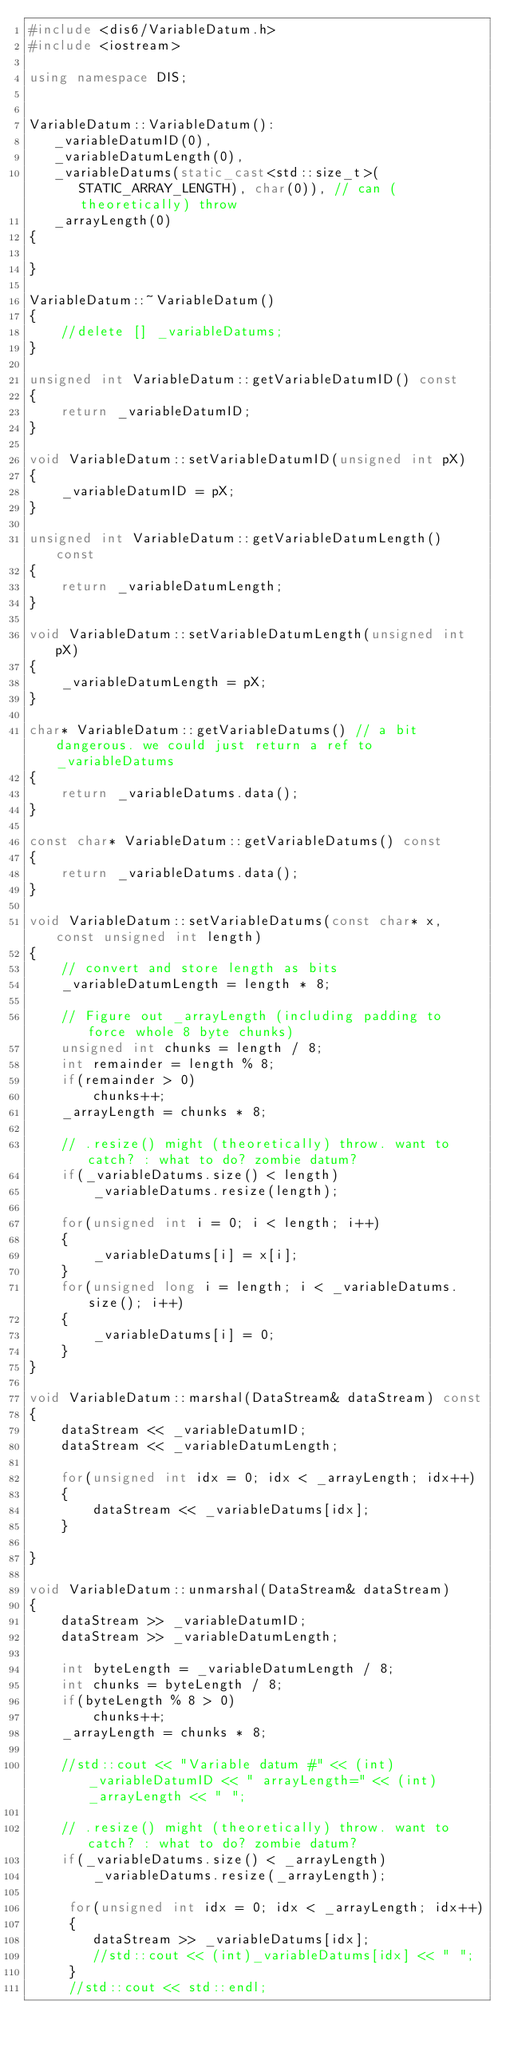Convert code to text. <code><loc_0><loc_0><loc_500><loc_500><_C++_>#include <dis6/VariableDatum.h>
#include <iostream>

using namespace DIS;


VariableDatum::VariableDatum():
   _variableDatumID(0), 
   _variableDatumLength(0),
   _variableDatums(static_cast<std::size_t>(STATIC_ARRAY_LENGTH), char(0)), // can (theoretically) throw
   _arrayLength(0)
{

}

VariableDatum::~VariableDatum()
{
	//delete [] _variableDatums;
}

unsigned int VariableDatum::getVariableDatumID() const
{
    return _variableDatumID;
}

void VariableDatum::setVariableDatumID(unsigned int pX)
{
    _variableDatumID = pX;
}

unsigned int VariableDatum::getVariableDatumLength() const
{
    return _variableDatumLength;
}

void VariableDatum::setVariableDatumLength(unsigned int pX)
{
    _variableDatumLength = pX;
}

char* VariableDatum::getVariableDatums() // a bit dangerous. we could just return a ref to _variableDatums
{
    return _variableDatums.data();
}

const char* VariableDatum::getVariableDatums() const
{
    return _variableDatums.data();
}

void VariableDatum::setVariableDatums(const char* x, const unsigned int length)
{
    // convert and store length as bits
    _variableDatumLength = length * 8;

    // Figure out _arrayLength (including padding to force whole 8 byte chunks)
    unsigned int chunks = length / 8;
    int remainder = length % 8;
    if(remainder > 0)
		chunks++;
    _arrayLength = chunks * 8;

    // .resize() might (theoretically) throw. want to catch? : what to do? zombie datum?
    if(_variableDatums.size() < length)
        _variableDatums.resize(length);

    for(unsigned int i = 0; i < length; i++)
    {
        _variableDatums[i] = x[i];
    }
    for(unsigned long i = length; i < _variableDatums.size(); i++)
    {
        _variableDatums[i] = 0;
    }
}

void VariableDatum::marshal(DataStream& dataStream) const
{
    dataStream << _variableDatumID;
    dataStream << _variableDatumLength;

    for(unsigned int idx = 0; idx < _arrayLength; idx++)
    {
        dataStream << _variableDatums[idx];
    }

}

void VariableDatum::unmarshal(DataStream& dataStream)
{
    dataStream >> _variableDatumID;
    dataStream >> _variableDatumLength;

    int byteLength = _variableDatumLength / 8;
	int chunks = byteLength / 8;
	if(byteLength % 8 > 0)
		chunks++;
	_arrayLength = chunks * 8;

	//std::cout << "Variable datum #" << (int)_variableDatumID << " arrayLength=" << (int)_arrayLength << " ";

    // .resize() might (theoretically) throw. want to catch? : what to do? zombie datum?
    if(_variableDatums.size() < _arrayLength)
        _variableDatums.resize(_arrayLength);

     for(unsigned int idx = 0; idx < _arrayLength; idx++)
     {
        dataStream >> _variableDatums[idx];
		//std::cout << (int)_variableDatums[idx] << " ";
     }
	 //std::cout << std::endl;</code> 